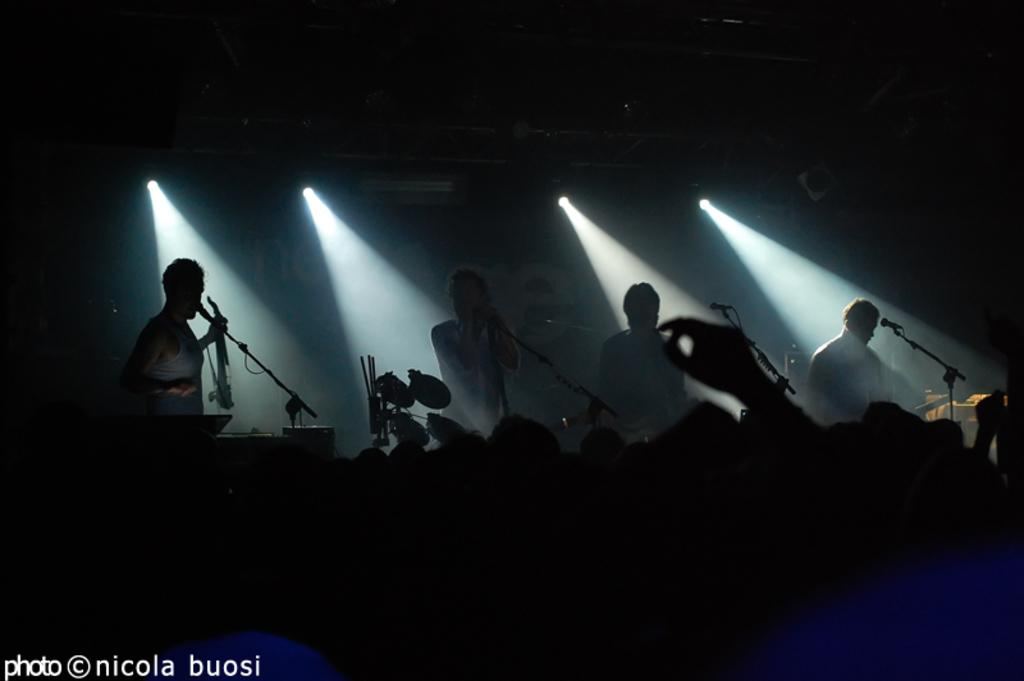Who or what is present in the image? There are people in the image. What objects can be seen with the people? There are microphones and lights in the image. Is there any text or logo on the image? Yes, the image has a watermark. How would you describe the lighting in the image? The image appears to be in a dark setting. What type of grain is visible on the people's toes in the image? There are no toes or grain visible in the image; it features people, microphones, and lights in a dark setting. 